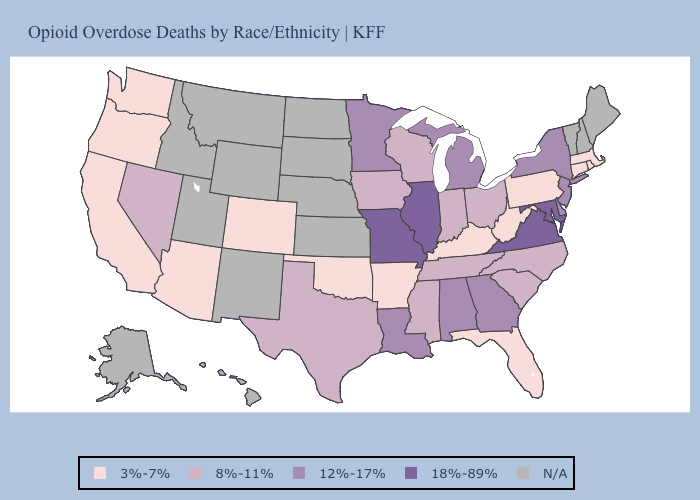Name the states that have a value in the range N/A?
Concise answer only. Alaska, Hawaii, Idaho, Kansas, Maine, Montana, Nebraska, New Hampshire, New Mexico, North Dakota, South Dakota, Utah, Vermont, Wyoming. What is the value of Maine?
Quick response, please. N/A. Which states have the lowest value in the South?
Be succinct. Arkansas, Florida, Kentucky, Oklahoma, West Virginia. What is the value of New York?
Write a very short answer. 12%-17%. What is the value of Utah?
Give a very brief answer. N/A. What is the value of Connecticut?
Concise answer only. 3%-7%. Among the states that border Indiana , which have the highest value?
Short answer required. Illinois. Name the states that have a value in the range N/A?
Short answer required. Alaska, Hawaii, Idaho, Kansas, Maine, Montana, Nebraska, New Hampshire, New Mexico, North Dakota, South Dakota, Utah, Vermont, Wyoming. What is the highest value in the USA?
Be succinct. 18%-89%. Name the states that have a value in the range 12%-17%?
Be succinct. Alabama, Delaware, Georgia, Louisiana, Michigan, Minnesota, New Jersey, New York. What is the highest value in states that border North Carolina?
Quick response, please. 18%-89%. What is the value of Colorado?
Keep it brief. 3%-7%. 